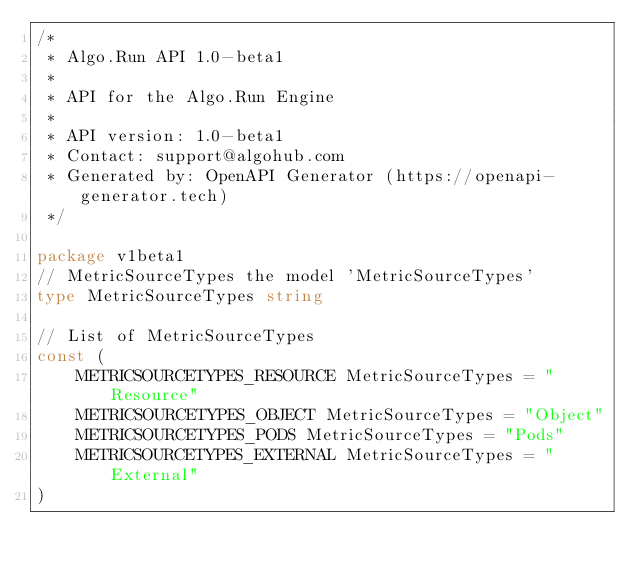Convert code to text. <code><loc_0><loc_0><loc_500><loc_500><_Go_>/*
 * Algo.Run API 1.0-beta1
 *
 * API for the Algo.Run Engine
 *
 * API version: 1.0-beta1
 * Contact: support@algohub.com
 * Generated by: OpenAPI Generator (https://openapi-generator.tech)
 */

package v1beta1
// MetricSourceTypes the model 'MetricSourceTypes'
type MetricSourceTypes string

// List of MetricSourceTypes
const (
	METRICSOURCETYPES_RESOURCE MetricSourceTypes = "Resource"
	METRICSOURCETYPES_OBJECT MetricSourceTypes = "Object"
	METRICSOURCETYPES_PODS MetricSourceTypes = "Pods"
	METRICSOURCETYPES_EXTERNAL MetricSourceTypes = "External"
)
</code> 